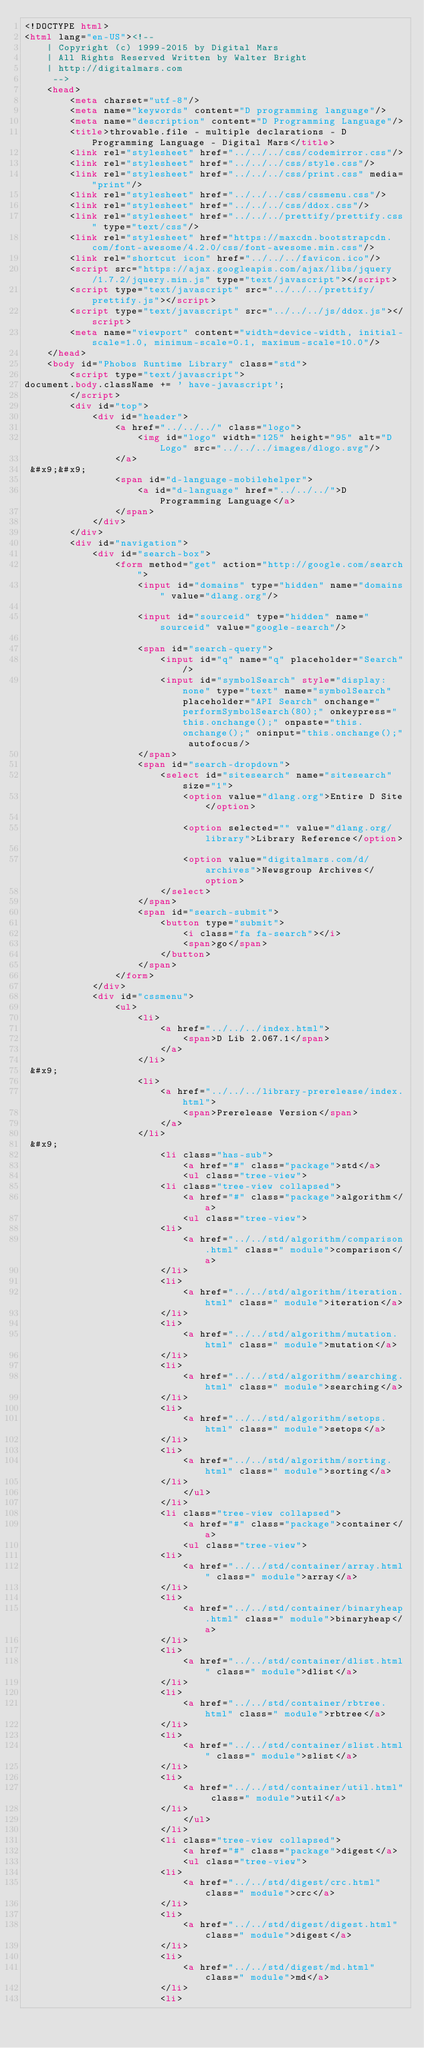<code> <loc_0><loc_0><loc_500><loc_500><_HTML_><!DOCTYPE html>
<html lang="en-US"><!-- 
    | Copyright (c) 1999-2015 by Digital Mars
    | All Rights Reserved Written by Walter Bright
    | http://digitalmars.com
	 -->
	<head>
		<meta charset="utf-8"/>
		<meta name="keywords" content="D programming language"/>
		<meta name="description" content="D Programming Language"/>
		<title>throwable.file - multiple declarations - D Programming Language - Digital Mars</title>
		<link rel="stylesheet" href="../../../css/codemirror.css"/>
		<link rel="stylesheet" href="../../../css/style.css"/>
		<link rel="stylesheet" href="../../../css/print.css" media="print"/>
		<link rel="stylesheet" href="../../../css/cssmenu.css"/>
		<link rel="stylesheet" href="../../../css/ddox.css"/>
		<link rel="stylesheet" href="../../../prettify/prettify.css" type="text/css"/>
		<link rel="stylesheet" href="https://maxcdn.bootstrapcdn.com/font-awesome/4.2.0/css/font-awesome.min.css"/>
		<link rel="shortcut icon" href="../../../favicon.ico"/>
		<script src="https://ajax.googleapis.com/ajax/libs/jquery/1.7.2/jquery.min.js" type="text/javascript"></script>
		<script type="text/javascript" src="../../../prettify/prettify.js"></script>
		<script type="text/javascript" src="../../../js/ddox.js"></script>
		<meta name="viewport" content="width=device-width, initial-scale=1.0, minimum-scale=0.1, maximum-scale=10.0"/>
	</head>
	<body id="Phobos Runtime Library" class="std">
		<script type="text/javascript">
document.body.className += ' have-javascript';
		</script>
		<div id="top">
			<div id="header">
				<a href="../../../" class="logo">
					<img id="logo" width="125" height="95" alt="D Logo" src="../../../images/dlogo.svg"/>
				</a>
 &#x9;&#x9;
				<span id="d-language-mobilehelper">
					<a id="d-language" href="../../../">D Programming Language</a>
				</span>
			</div>
		</div>
		<div id="navigation">
			<div id="search-box">
				<form method="get" action="http://google.com/search">
					<input id="domains" type="hidden" name="domains" value="dlang.org"/>
             
					<input id="sourceid" type="hidden" name="sourceid" value="google-search"/>
             
					<span id="search-query">
						<input id="q" name="q" placeholder="Search"/>
						<input id="symbolSearch" style="display: none" type="text" name="symbolSearch" placeholder="API Search" onchange="performSymbolSearch(80);" onkeypress="this.onchange();" onpaste="this.onchange();" oninput="this.onchange();" autofocus/>
					</span>
					<span id="search-dropdown">
						<select id="sitesearch" name="sitesearch" size="1">
							<option value="dlang.org">Entire D Site</option>
                     
							<option selected="" value="dlang.org/library">Library Reference</option>
                     
							<option value="digitalmars.com/d/archives">Newsgroup Archives</option>
						</select>
					</span>
					<span id="search-submit">
						<button type="submit">
							<i class="fa fa-search"></i>
							<span>go</span>
						</button>
					</span>
				</form>
			</div>
			<div id="cssmenu">
				<ul>
					<li>
						<a href="../../../index.html">
							<span>D Lib 2.067.1</span>
						</a>
					</li>
 &#x9;
					<li>
						<a href="../../../library-prerelease/index.html">
							<span>Prerelease Version</span>
						</a>
					</li>
 &#x9;
						<li class="has-sub">
							<a href="#" class="package">std</a>
							<ul class="tree-view">
						<li class="tree-view collapsed">
							<a href="#" class="package">algorithm</a>
							<ul class="tree-view">
						<li>
							<a href="../../std/algorithm/comparison.html" class=" module">comparison</a>
						</li>
						<li>
							<a href="../../std/algorithm/iteration.html" class=" module">iteration</a>
						</li>
						<li>
							<a href="../../std/algorithm/mutation.html" class=" module">mutation</a>
						</li>
						<li>
							<a href="../../std/algorithm/searching.html" class=" module">searching</a>
						</li>
						<li>
							<a href="../../std/algorithm/setops.html" class=" module">setops</a>
						</li>
						<li>
							<a href="../../std/algorithm/sorting.html" class=" module">sorting</a>
						</li>
							</ul>
						</li>
						<li class="tree-view collapsed">
							<a href="#" class="package">container</a>
							<ul class="tree-view">
						<li>
							<a href="../../std/container/array.html" class=" module">array</a>
						</li>
						<li>
							<a href="../../std/container/binaryheap.html" class=" module">binaryheap</a>
						</li>
						<li>
							<a href="../../std/container/dlist.html" class=" module">dlist</a>
						</li>
						<li>
							<a href="../../std/container/rbtree.html" class=" module">rbtree</a>
						</li>
						<li>
							<a href="../../std/container/slist.html" class=" module">slist</a>
						</li>
						<li>
							<a href="../../std/container/util.html" class=" module">util</a>
						</li>
							</ul>
						</li>
						<li class="tree-view collapsed">
							<a href="#" class="package">digest</a>
							<ul class="tree-view">
						<li>
							<a href="../../std/digest/crc.html" class=" module">crc</a>
						</li>
						<li>
							<a href="../../std/digest/digest.html" class=" module">digest</a>
						</li>
						<li>
							<a href="../../std/digest/md.html" class=" module">md</a>
						</li>
						<li></code> 